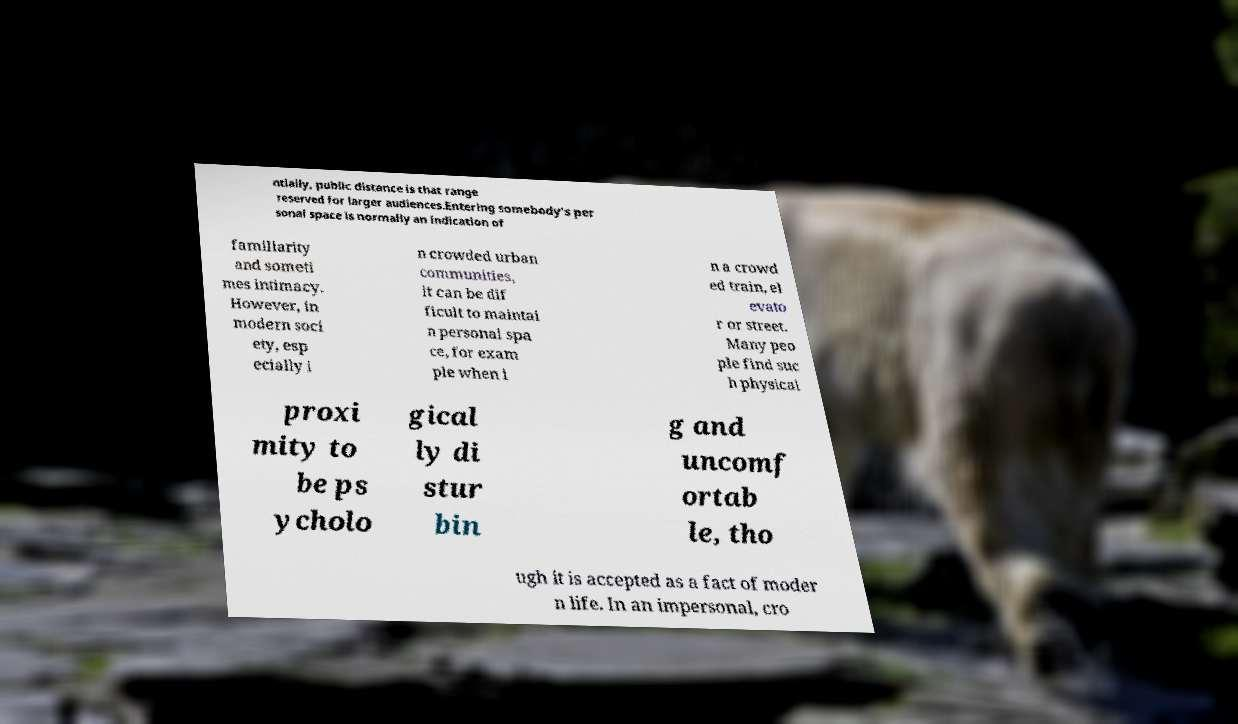What messages or text are displayed in this image? I need them in a readable, typed format. ntially, public distance is that range reserved for larger audiences.Entering somebody's per sonal space is normally an indication of familiarity and someti mes intimacy. However, in modern soci ety, esp ecially i n crowded urban communities, it can be dif ficult to maintai n personal spa ce, for exam ple when i n a crowd ed train, el evato r or street. Many peo ple find suc h physical proxi mity to be ps ycholo gical ly di stur bin g and uncomf ortab le, tho ugh it is accepted as a fact of moder n life. In an impersonal, cro 